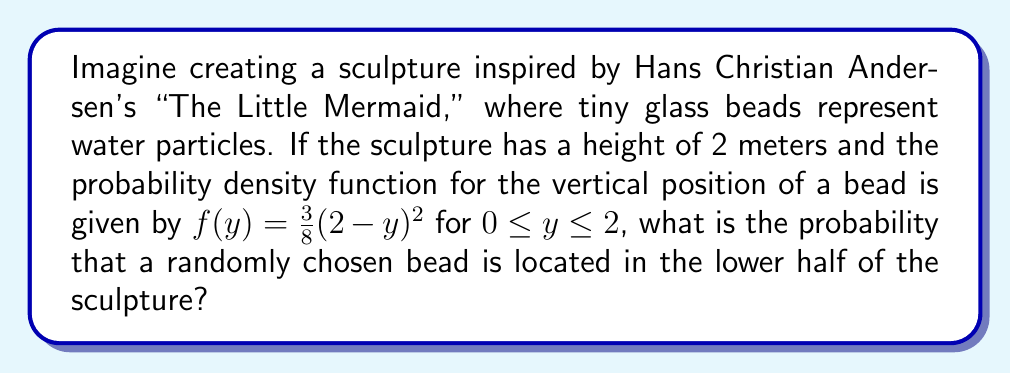Show me your answer to this math problem. To solve this problem, we need to integrate the probability density function over the lower half of the sculpture. Let's approach this step-by-step:

1) The sculpture's height is 2 meters, so the lower half is from 0 to 1 meter.

2) We need to integrate the given probability density function from 0 to 1:

   $$P(0 \leq Y \leq 1) = \int_0^1 f(y) dy = \int_0^1 \frac{3}{8}(2-y)^2 dy$$

3) Let's solve this integral:

   $$\int_0^1 \frac{3}{8}(2-y)^2 dy = \frac{3}{8} \int_0^1 (4-4y+y^2) dy$$

4) Integrating term by term:

   $$\frac{3}{8} \left[4y - 2y^2 + \frac{1}{3}y^3\right]_0^1$$

5) Evaluating at the limits:

   $$\frac{3}{8} \left[(4 - 2 + \frac{1}{3}) - (0 - 0 + 0)\right] = \frac{3}{8} \left(\frac{7}{3}\right)$$

6) Simplifying:

   $$\frac{3}{8} \cdot \frac{7}{3} = \frac{7}{8} = 0.875$$

Therefore, the probability that a randomly chosen bead is in the lower half of the sculpture is 0.875 or 87.5%.
Answer: $\frac{7}{8}$ or 0.875 